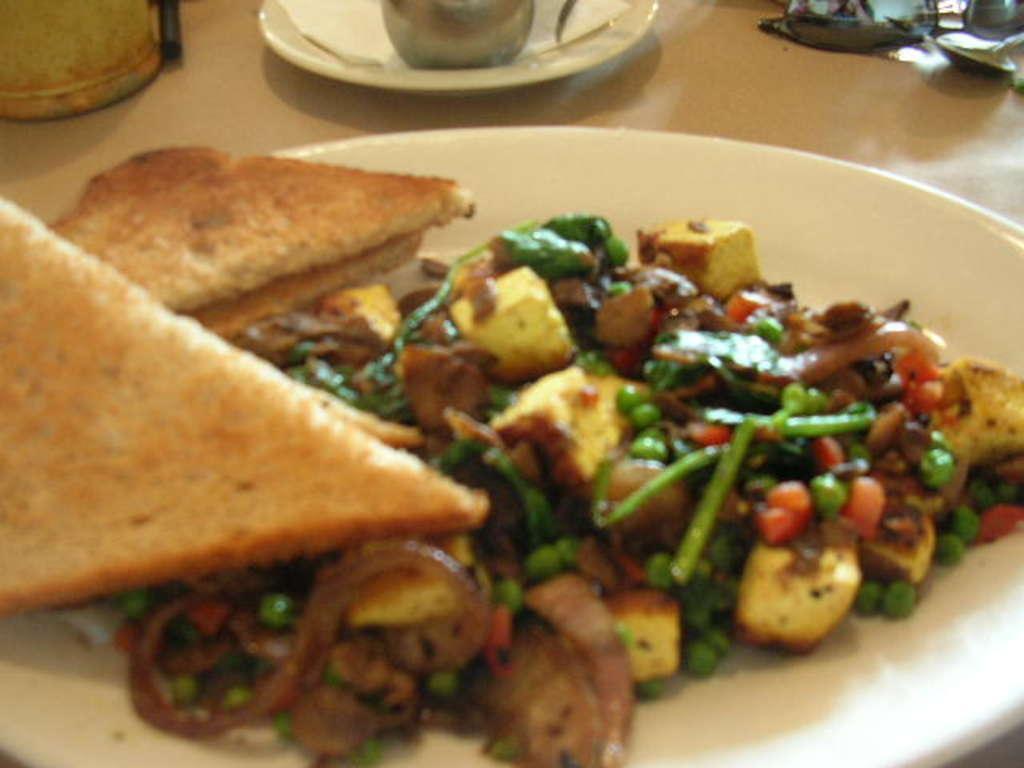Please provide a concise description of this image. Here we can see plates, food, tissue paper, and objects on a platform. 